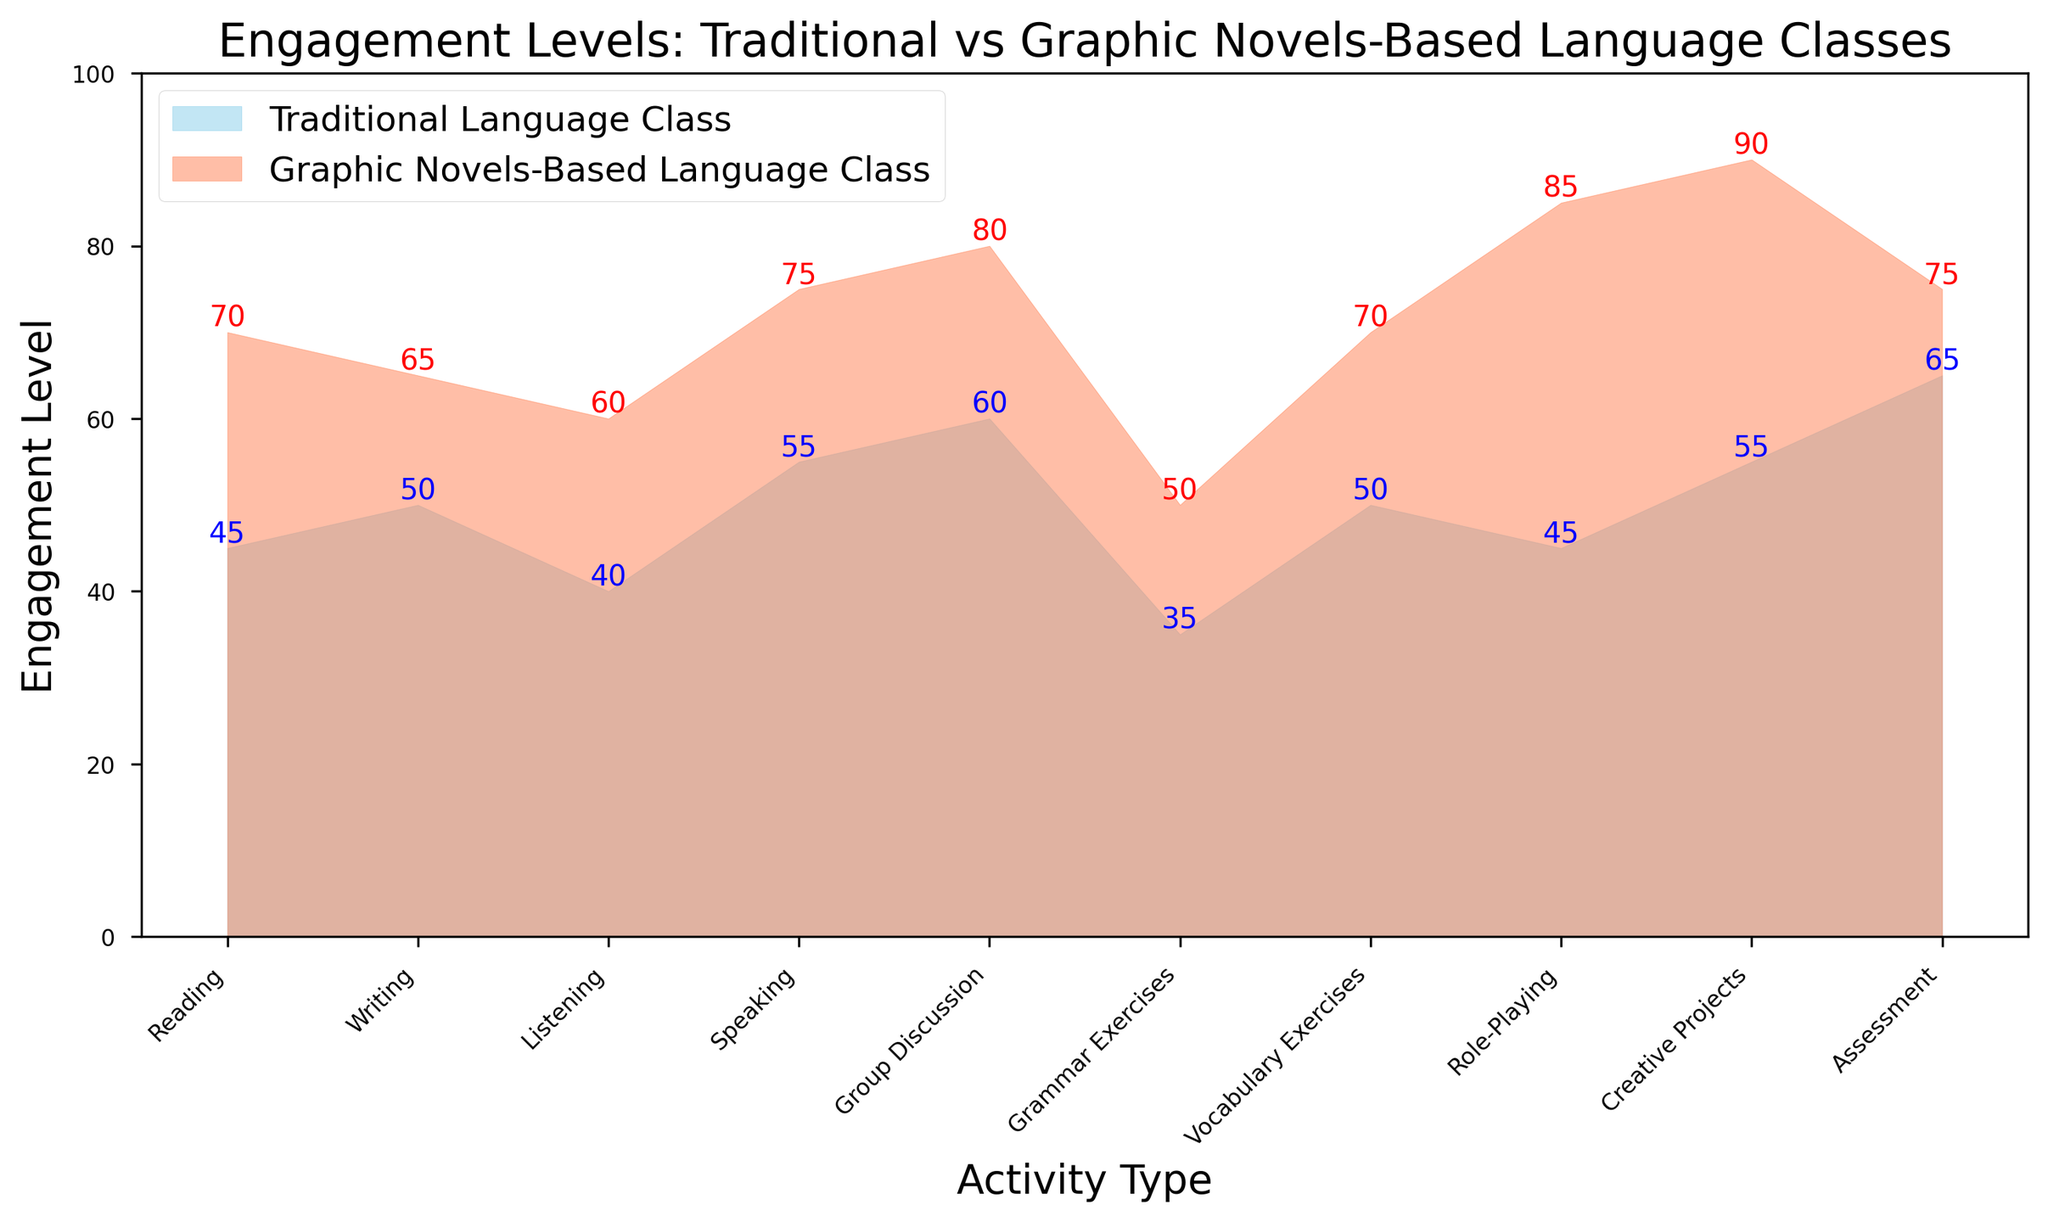What is the difference in engagement levels between Graphic Novels-Based Language Class and Traditional Language Class for the activity "Reading"? To find the difference, subtract the engagement level of Traditional Language Class for "Reading" (45) from the engagement level of Graphic Novels-Based Language Class for "Reading" (70). 70 - 45 = 25
Answer: 25 Which activity shows the highest engagement level in Graphic Novels-Based Language Class? To determine this, observe the engagement levels for all activities in the Graphic Novels-Based Language Class and identify the highest value. The highest engagement level is 90 for "Creative Projects".
Answer: Creative Projects How does the engagement level for "Role-Playing" compare between the two types of language classes? Compare the engagement levels for "Role-Playing" in both classes. The Traditional Language Class has an engagement level of 45, whereas the Graphic Novels-Based Language Class has an engagement level of 85. 85 is greater than 45.
Answer: Graphic Novels-Based Language Class has a higher engagement level for Role-Playing What is the average engagement level for "Writing" and "Speaking" activities in the Traditional Language Class? To find the average, first sum the engagement levels for "Writing" (50) and "Speaking" (55). Then divide by the number of activities: (50 + 55) / 2 = 105 / 2 = 52.5
Answer: 52.5 Which type of language class has a higher engagement level for "Listening"? Compare the engagement levels for "Listening" in both classes. The Traditional Language Class has an engagement level of 40, and the Graphic Novels-Based Language Class has an engagement level of 60. 60 is greater than 40.
Answer: Graphic Novels-Based Language Class What is the total engagement level for all activities in the Graphic Novels-Based Language Class? Sum the engagement levels for all activities in the Graphic Novels-Based Language Class: 70 + 65 + 60 + 75 + 80 + 50 + 70 + 85 + 90 + 75 = 720
Answer: 720 Which activities have an equal engagement level in Traditional Language Class and Graphic Novels-Based Language Class? Observe the engagement levels for each activity in both classes and identify any that are equal. None of the activities have equal engagement levels.
Answer: None What is the combined engagement level for "Grammar Exercises" and "Assessment" in Traditional Language Class? To find the combined engagement level, sum the levels for "Grammar Exercises" (35) and "Assessment" (65): 35 + 65 = 100
Answer: 100 How much higher is the engagement level for "Speaking" in Graphic Novels-Based Language Class compared to Traditional Language Class? Subtract the engagement level for "Speaking" in Traditional Language Class (55) from that in Graphic Novels-Based Language Class (75): 75 - 55 = 20
Answer: 20 Which class shows a more significant improvement in engagement during "Creative Projects" compared to "Grammar Exercises"? Calculate the difference in engagement levels for "Creative Projects" and "Grammar Exercises" in both classes. Traditional Language Class: 55 - 35 = 20. Graphic Novels-Based Language Class: 90 - 50 = 40. Graphic Novels-Based Language Class shows a more significant improvement (40 vs 20).
Answer: Graphic Novels-Based Language Class 